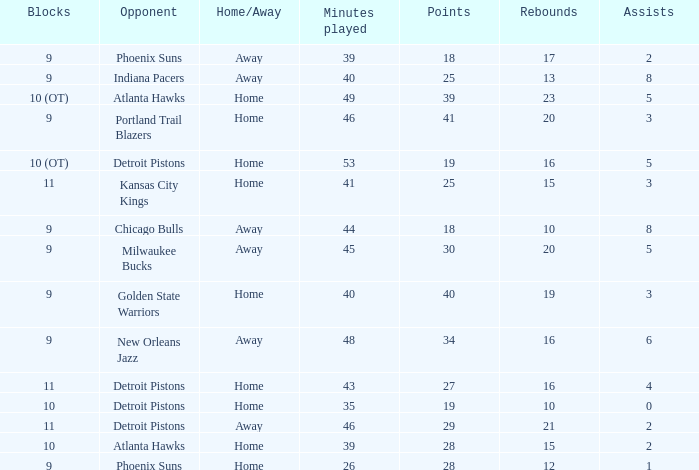How many points were there when there were fewer than 16 rebounds and 5 assists? 0.0. 